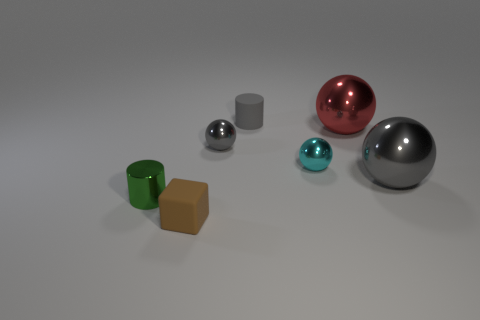Add 3 large red spheres. How many objects exist? 10 Subtract all balls. How many objects are left? 3 Add 5 green cylinders. How many green cylinders exist? 6 Subtract 0 purple spheres. How many objects are left? 7 Subtract all cyan spheres. Subtract all tiny gray matte cylinders. How many objects are left? 5 Add 6 tiny metal cylinders. How many tiny metal cylinders are left? 7 